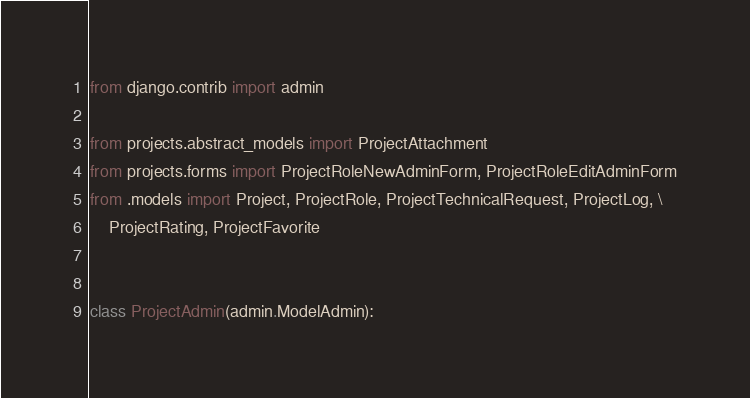Convert code to text. <code><loc_0><loc_0><loc_500><loc_500><_Python_>from django.contrib import admin

from projects.abstract_models import ProjectAttachment
from projects.forms import ProjectRoleNewAdminForm, ProjectRoleEditAdminForm
from .models import Project, ProjectRole, ProjectTechnicalRequest, ProjectLog, \
    ProjectRating, ProjectFavorite


class ProjectAdmin(admin.ModelAdmin):</code> 